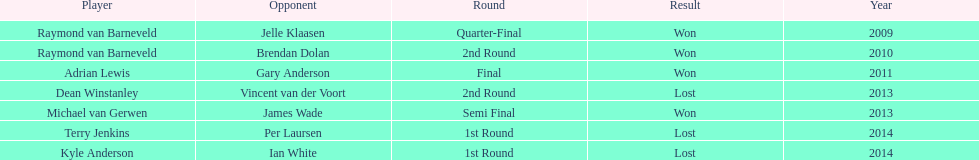Who are the only players listed that played in 2011? Adrian Lewis. 